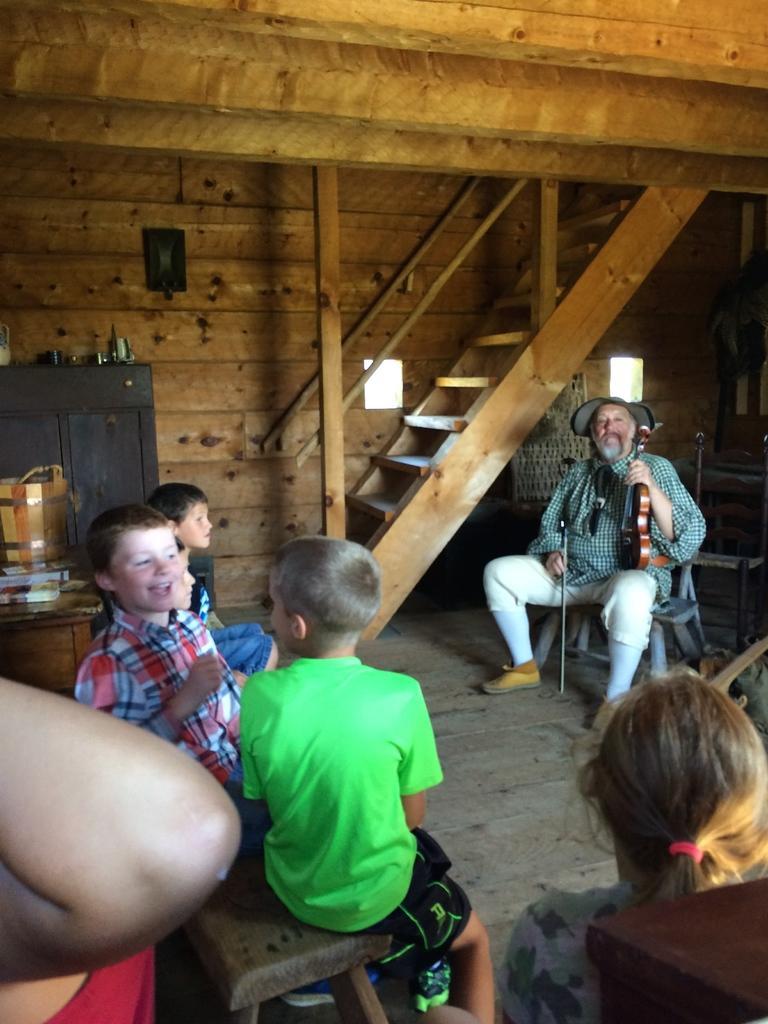Can you describe this image briefly? In the image there are few children sitting on the bench. On the left side of the image there is an elbow of a person. And in the bottom right corner of the image there is a table. Behind the table there is a person. There is a man with a cap on his head and he is sitting on a chair and holding a musical instrument in his hand. Behind him there are steps and also there is railing. On the left side of the image there is a table with few objects on it. Behind the table there is a cupboard. At the top of the image there is a wooden roof. 